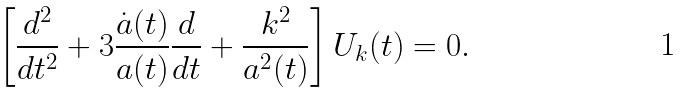Convert formula to latex. <formula><loc_0><loc_0><loc_500><loc_500>\left [ \frac { d ^ { 2 } } { d t ^ { 2 } } + 3 \frac { \dot { a } ( t ) } { a ( t ) } \frac { d } { d t } + \frac { k ^ { 2 } } { a ^ { 2 } ( t ) } \right ] U _ { k } ( t ) = 0 .</formula> 